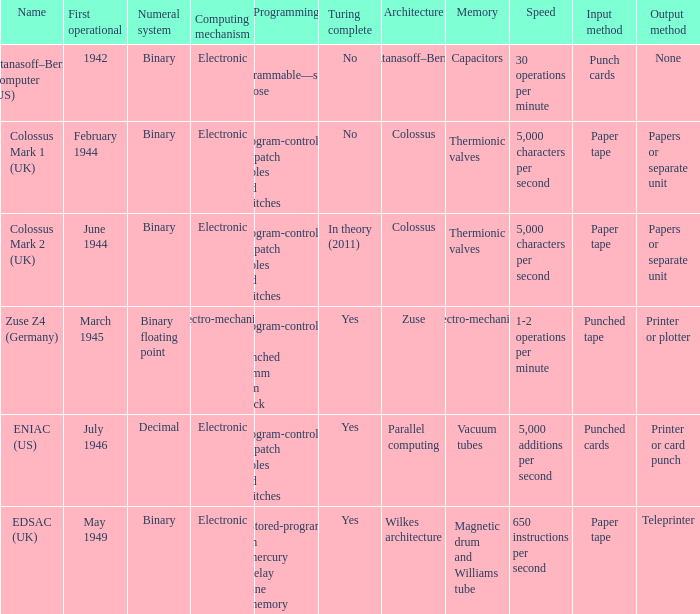What's the name with first operational being march 1945 Zuse Z4 (Germany). 